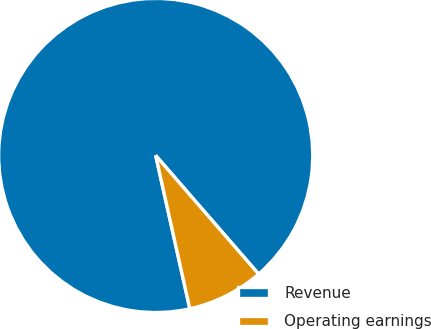Convert chart. <chart><loc_0><loc_0><loc_500><loc_500><pie_chart><fcel>Revenue<fcel>Operating earnings<nl><fcel>92.11%<fcel>7.89%<nl></chart> 